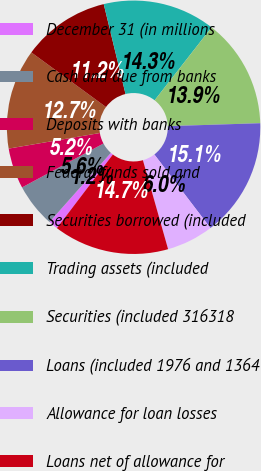Convert chart. <chart><loc_0><loc_0><loc_500><loc_500><pie_chart><fcel>December 31 (in millions<fcel>Cash and due from banks<fcel>Deposits with banks<fcel>Federal funds sold and<fcel>Securities borrowed (included<fcel>Trading assets (included<fcel>Securities (included 316318<fcel>Loans (included 1976 and 1364<fcel>Allowance for loan losses<fcel>Loans net of allowance for<nl><fcel>1.2%<fcel>5.58%<fcel>5.18%<fcel>12.75%<fcel>11.16%<fcel>14.34%<fcel>13.94%<fcel>15.14%<fcel>5.98%<fcel>14.74%<nl></chart> 